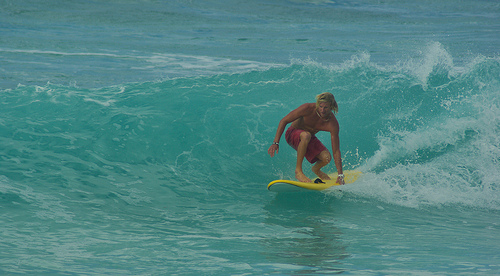Is the surfboard blue or yellow? The surfboard that the individual is skillfully maneuvering is primarily yellow, with vibrant appeal. 